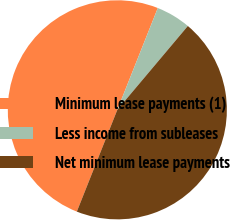Convert chart. <chart><loc_0><loc_0><loc_500><loc_500><pie_chart><fcel>Minimum lease payments (1)<fcel>Less income from subleases<fcel>Net minimum lease payments<nl><fcel>50.0%<fcel>5.11%<fcel>44.89%<nl></chart> 